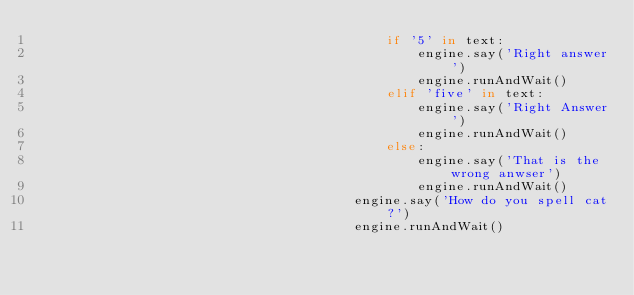<code> <loc_0><loc_0><loc_500><loc_500><_Python_>                                            if '5' in text:
                                                engine.say('Right answer')
                                                engine.runAndWait()
                                            elif 'five' in text:
                                                engine.say('Right Answer')
                                                engine.runAndWait()
                                            else:
                                                engine.say('That is the wrong anwser')
                                                engine.runAndWait()
                                        engine.say('How do you spell cat?')
                                        engine.runAndWait()</code> 